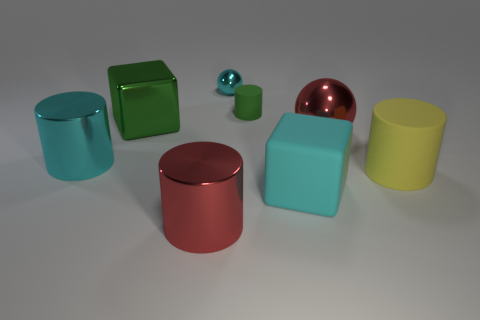Subtract all big cyan metallic cylinders. How many cylinders are left? 3 Subtract all cyan spheres. How many spheres are left? 1 Add 6 small objects. How many small objects are left? 8 Add 3 tiny cyan cylinders. How many tiny cyan cylinders exist? 3 Add 1 tiny cyan spheres. How many objects exist? 9 Subtract 1 red cylinders. How many objects are left? 7 Subtract all blocks. How many objects are left? 6 Subtract 1 balls. How many balls are left? 1 Subtract all yellow cylinders. Subtract all red spheres. How many cylinders are left? 3 Subtract all gray blocks. How many brown cylinders are left? 0 